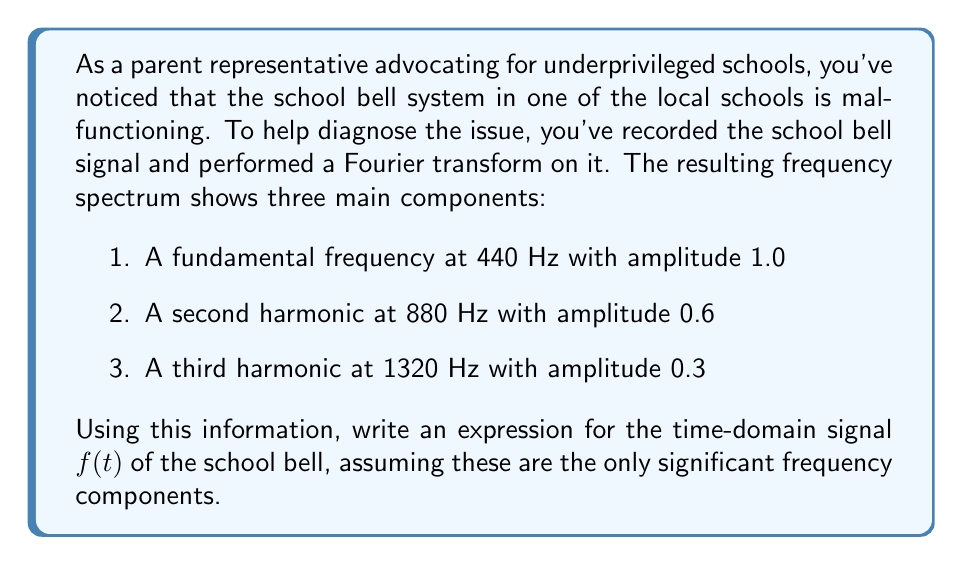Show me your answer to this math problem. To solve this problem, we need to use the inverse Fourier transform concept to convert the frequency domain information into a time-domain signal. Each frequency component will contribute a sinusoidal term to the overall signal.

Step 1: Express each frequency component as a cosine function.
- For the fundamental frequency: $1.0 \cos(2\pi \cdot 440t)$
- For the second harmonic: $0.6 \cos(2\pi \cdot 880t)$
- For the third harmonic: $0.3 \cos(2\pi \cdot 1320t)$

Step 2: Sum these components to get the time-domain signal.
$$f(t) = 1.0 \cos(2\pi \cdot 440t) + 0.6 \cos(2\pi \cdot 880t) + 0.3 \cos(2\pi \cdot 1320t)$$

Step 3: Simplify by factoring out $2\pi$ and expressing the frequencies in terms of the fundamental.
$$f(t) = 1.0 \cos(2\pi \cdot 440t) + 0.6 \cos(2\pi \cdot 2 \cdot 440t) + 0.3 \cos(2\pi \cdot 3 \cdot 440t)$$

Step 4: Let $\omega = 2\pi \cdot 440$ to further simplify the expression.
$$f(t) = 1.0 \cos(\omega t) + 0.6 \cos(2\omega t) + 0.3 \cos(3\omega t)$$

This final expression represents the time-domain signal of the school bell based on the given frequency components.
Answer: $$f(t) = 1.0 \cos(\omega t) + 0.6 \cos(2\omega t) + 0.3 \cos(3\omega t)$$
where $\omega = 2\pi \cdot 440$ rad/s 